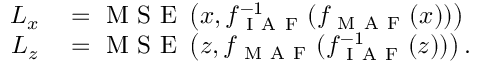<formula> <loc_0><loc_0><loc_500><loc_500>\begin{array} { r l } { L _ { x } } & = M S E \left ( x , f _ { I A F } ^ { - 1 } ( f _ { M A F } ( x ) ) \right ) } \\ { L _ { z } } & = M S E \left ( z , f _ { M A F } ( f _ { I A F } ^ { - 1 } ( z ) ) \right ) . } \end{array}</formula> 